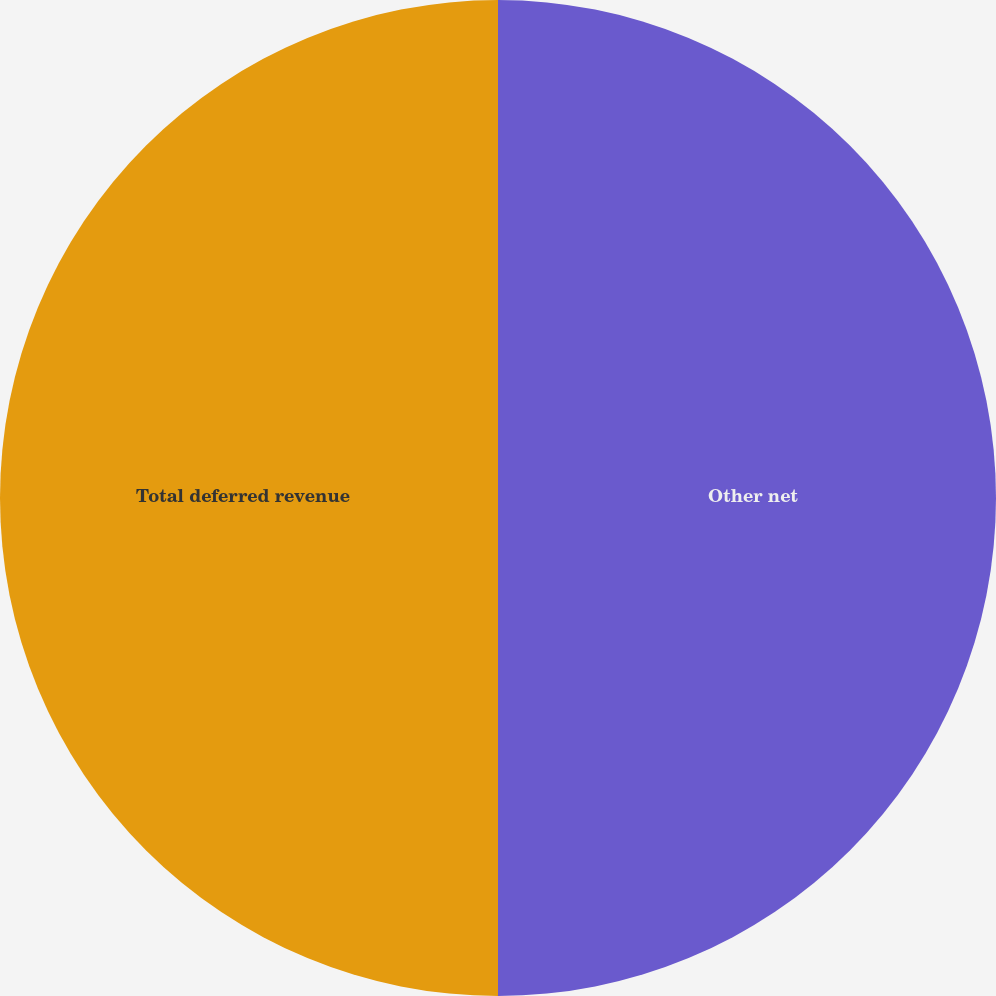<chart> <loc_0><loc_0><loc_500><loc_500><pie_chart><fcel>Other net<fcel>Total deferred revenue<nl><fcel>50.0%<fcel>50.0%<nl></chart> 